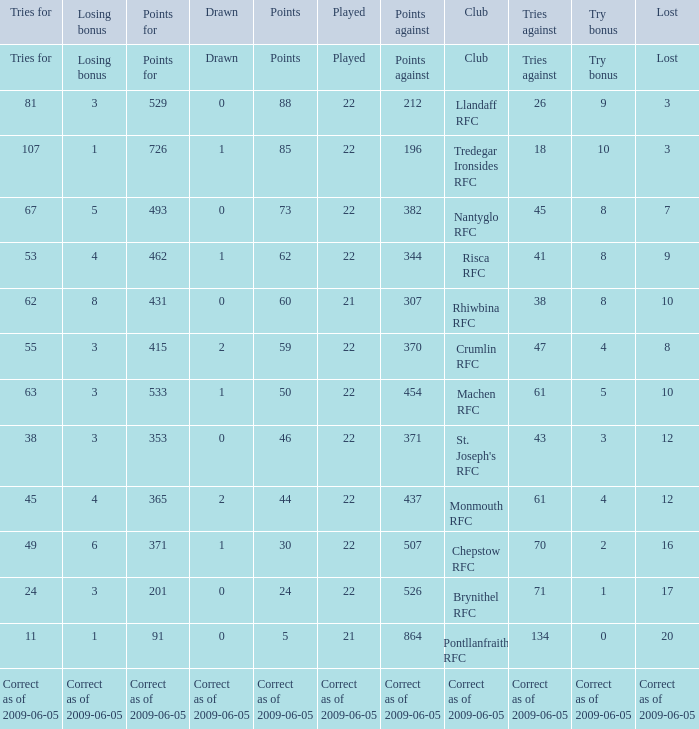What's the losing bonus of Crumlin RFC? 3.0. 